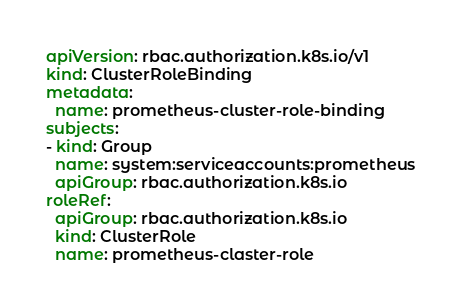Convert code to text. <code><loc_0><loc_0><loc_500><loc_500><_YAML_>apiVersion: rbac.authorization.k8s.io/v1
kind: ClusterRoleBinding
metadata:
  name: prometheus-cluster-role-binding
subjects:
- kind: Group
  name: system:serviceaccounts:prometheus
  apiGroup: rbac.authorization.k8s.io
roleRef:
  apiGroup: rbac.authorization.k8s.io
  kind: ClusterRole
  name: prometheus-claster-role

</code> 